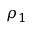Convert formula to latex. <formula><loc_0><loc_0><loc_500><loc_500>\rho _ { 1 }</formula> 